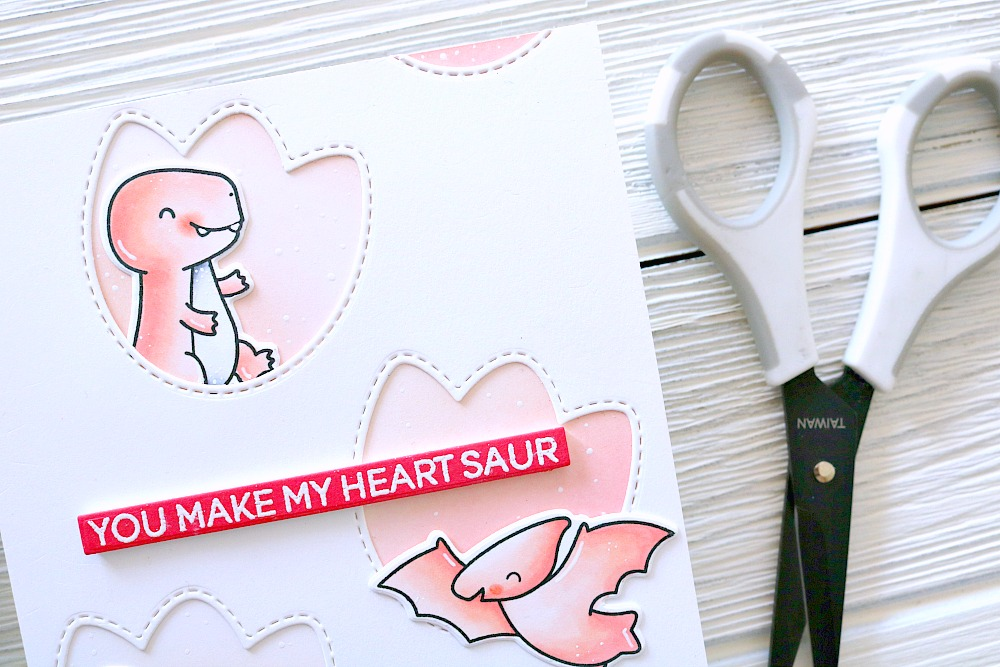What artistic techniques may have been used to create the textured background of the card, and how do these techniques contribute to the overall aesthetic of the craft? The card features a delicately textured background likely achieved through a combination of dry embossing and carefully applied sponge painting. Dry embossing involves using a stencil and tool to raise the paper’s surface, lending a luxurious, tactile dimension. Sponge painting might have been employed to subtly layer paint, infusing the background with a soft, variegated appearance. These artistic techniques jointly heighten the card's aesthetic appeal by adding depth and invoking a handmade charm, which is particularly engaging alongside the card's playful and heartfelt imagery of dinosaurs. The use of embossed dots to imitate stitching reinforces this craft's bespoke nature, potentially enriching its appeal and emotional resonance for the recipient. 